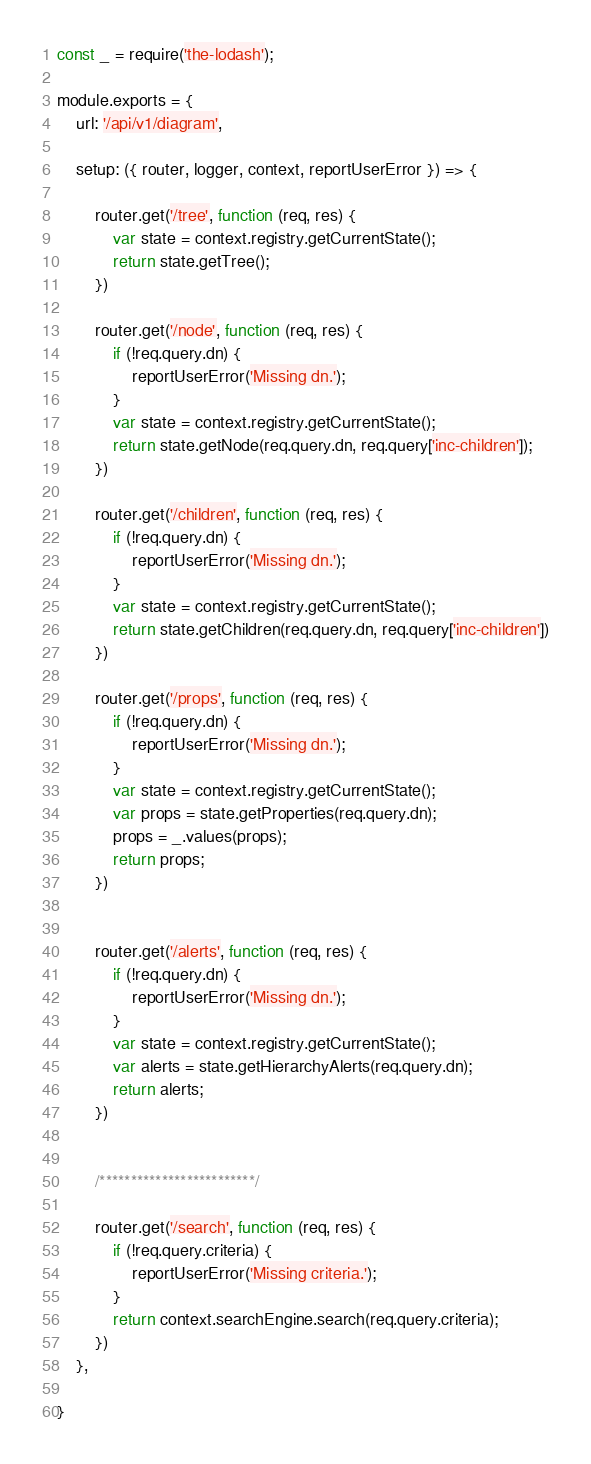Convert code to text. <code><loc_0><loc_0><loc_500><loc_500><_JavaScript_>const _ = require('the-lodash');

module.exports = {
    url: '/api/v1/diagram',

    setup: ({ router, logger, context, reportUserError }) => {

        router.get('/tree', function (req, res) {
            var state = context.registry.getCurrentState();
            return state.getTree();
        })

        router.get('/node', function (req, res) {
            if (!req.query.dn) {
                reportUserError('Missing dn.');
            }
            var state = context.registry.getCurrentState();
            return state.getNode(req.query.dn, req.query['inc-children']);
        })

        router.get('/children', function (req, res) {
            if (!req.query.dn) {
                reportUserError('Missing dn.');
            }
            var state = context.registry.getCurrentState();
            return state.getChildren(req.query.dn, req.query['inc-children'])
        })

        router.get('/props', function (req, res) {
            if (!req.query.dn) {
                reportUserError('Missing dn.');
            }
            var state = context.registry.getCurrentState();
            var props = state.getProperties(req.query.dn);
            props = _.values(props);
            return props;
        })


        router.get('/alerts', function (req, res) {
            if (!req.query.dn) {
                reportUserError('Missing dn.');
            }
            var state = context.registry.getCurrentState();
            var alerts = state.getHierarchyAlerts(req.query.dn);
            return alerts;
        })


        /*************************/

        router.get('/search', function (req, res) {
            if (!req.query.criteria) {
                reportUserError('Missing criteria.');
            }
            return context.searchEngine.search(req.query.criteria);
        })
    },

}
</code> 